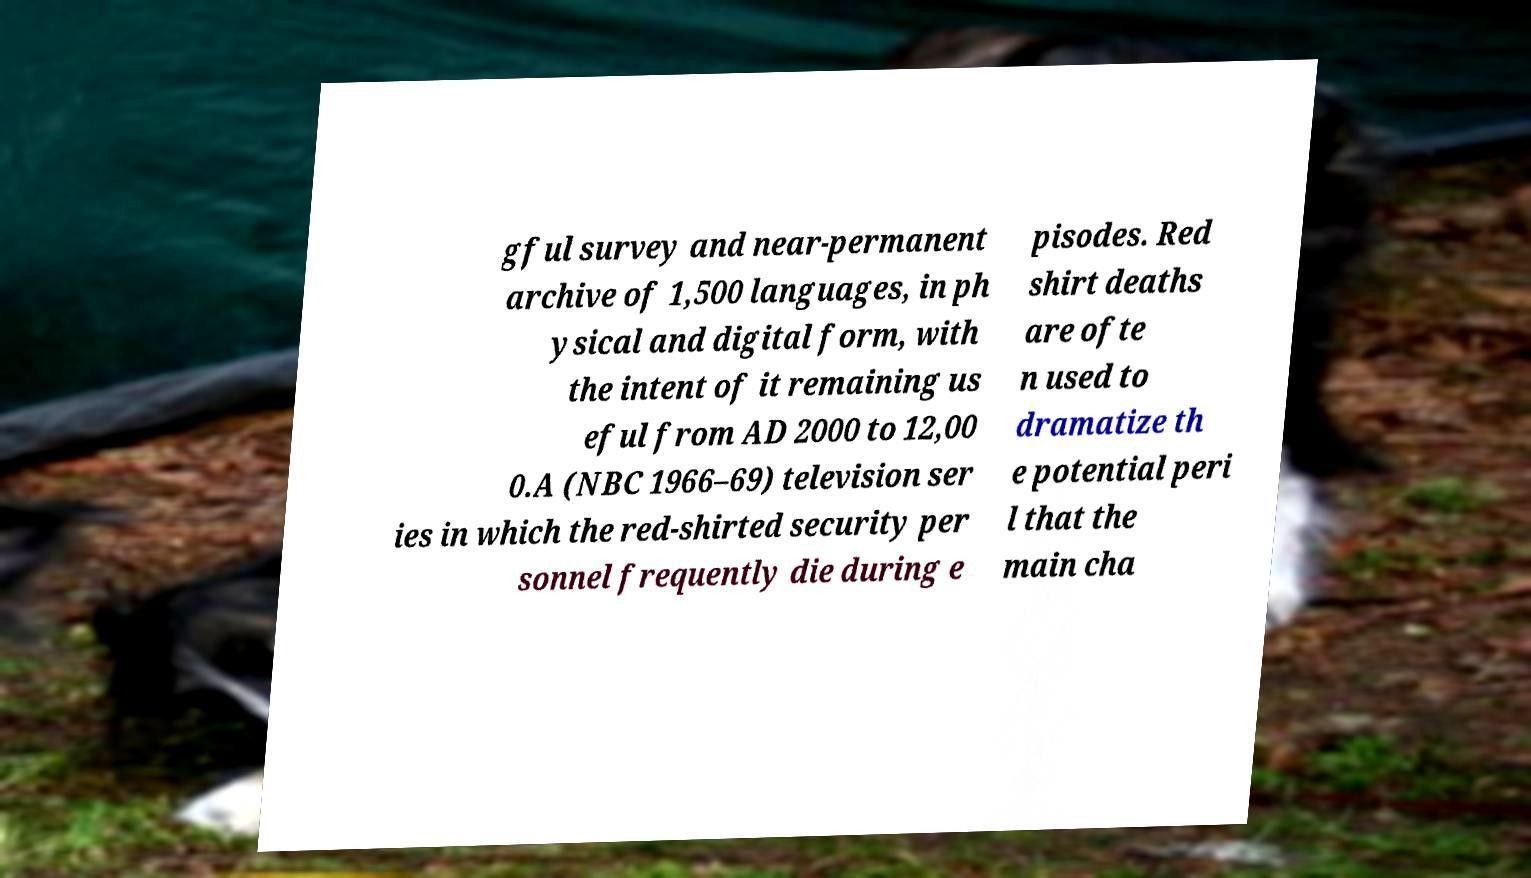Please read and relay the text visible in this image. What does it say? gful survey and near-permanent archive of 1,500 languages, in ph ysical and digital form, with the intent of it remaining us eful from AD 2000 to 12,00 0.A (NBC 1966–69) television ser ies in which the red-shirted security per sonnel frequently die during e pisodes. Red shirt deaths are ofte n used to dramatize th e potential peri l that the main cha 